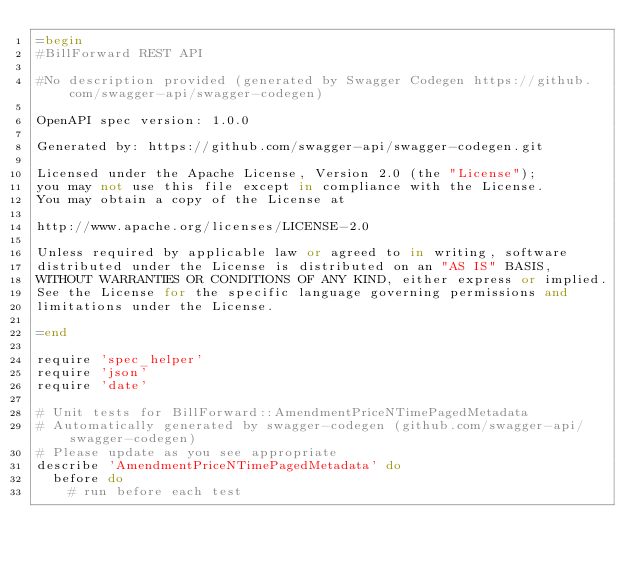Convert code to text. <code><loc_0><loc_0><loc_500><loc_500><_Ruby_>=begin
#BillForward REST API

#No description provided (generated by Swagger Codegen https://github.com/swagger-api/swagger-codegen)

OpenAPI spec version: 1.0.0

Generated by: https://github.com/swagger-api/swagger-codegen.git

Licensed under the Apache License, Version 2.0 (the "License");
you may not use this file except in compliance with the License.
You may obtain a copy of the License at

http://www.apache.org/licenses/LICENSE-2.0

Unless required by applicable law or agreed to in writing, software
distributed under the License is distributed on an "AS IS" BASIS,
WITHOUT WARRANTIES OR CONDITIONS OF ANY KIND, either express or implied.
See the License for the specific language governing permissions and
limitations under the License.

=end

require 'spec_helper'
require 'json'
require 'date'

# Unit tests for BillForward::AmendmentPriceNTimePagedMetadata
# Automatically generated by swagger-codegen (github.com/swagger-api/swagger-codegen)
# Please update as you see appropriate
describe 'AmendmentPriceNTimePagedMetadata' do
  before do
    # run before each test</code> 